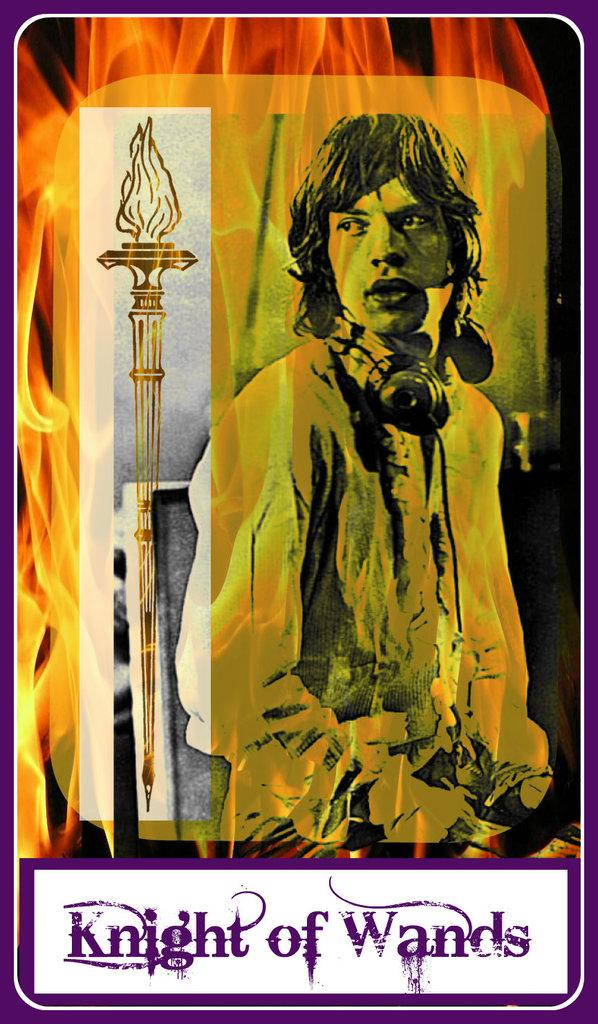<image>
Provide a brief description of the given image. The Knight of Wands tarot card with an image of flames on it. 